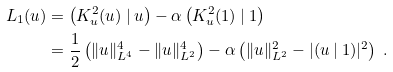<formula> <loc_0><loc_0><loc_500><loc_500>L _ { 1 } ( u ) & = \left ( K _ { u } ^ { 2 } ( u ) \ | \ u \right ) - \alpha \left ( K _ { u } ^ { 2 } ( 1 ) \ | \ 1 \right ) \\ & = \frac { 1 } { 2 } \left ( \| u \| _ { L ^ { 4 } } ^ { 4 } - \| u \| _ { L ^ { 2 } } ^ { 4 } \right ) - \alpha \left ( \| u \| _ { L ^ { 2 } } ^ { 2 } - | ( u \ | \ 1 ) | ^ { 2 } \right ) \ .</formula> 